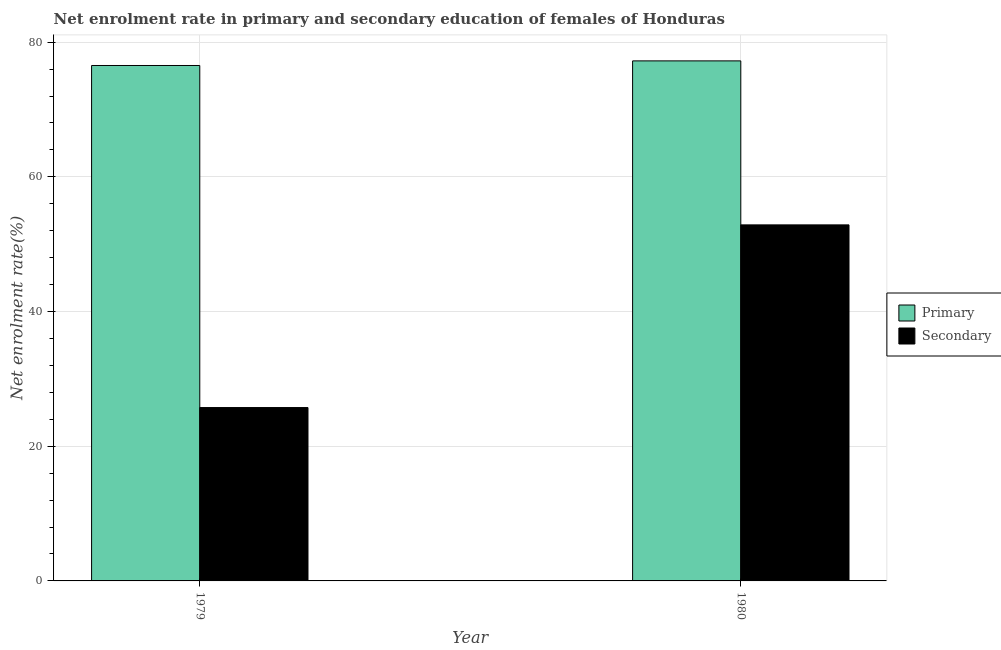How many different coloured bars are there?
Keep it short and to the point. 2. How many bars are there on the 1st tick from the left?
Provide a succinct answer. 2. In how many cases, is the number of bars for a given year not equal to the number of legend labels?
Your answer should be very brief. 0. What is the enrollment rate in secondary education in 1980?
Offer a very short reply. 52.87. Across all years, what is the maximum enrollment rate in secondary education?
Offer a terse response. 52.87. Across all years, what is the minimum enrollment rate in secondary education?
Offer a terse response. 25.74. In which year was the enrollment rate in secondary education minimum?
Provide a succinct answer. 1979. What is the total enrollment rate in secondary education in the graph?
Offer a terse response. 78.61. What is the difference between the enrollment rate in primary education in 1979 and that in 1980?
Your answer should be compact. -0.68. What is the difference between the enrollment rate in primary education in 1979 and the enrollment rate in secondary education in 1980?
Your answer should be very brief. -0.68. What is the average enrollment rate in secondary education per year?
Your response must be concise. 39.31. What is the ratio of the enrollment rate in primary education in 1979 to that in 1980?
Ensure brevity in your answer.  0.99. What does the 1st bar from the left in 1979 represents?
Ensure brevity in your answer.  Primary. What does the 1st bar from the right in 1979 represents?
Provide a succinct answer. Secondary. How many bars are there?
Provide a succinct answer. 4. How many years are there in the graph?
Provide a succinct answer. 2. Are the values on the major ticks of Y-axis written in scientific E-notation?
Keep it short and to the point. No. What is the title of the graph?
Your answer should be compact. Net enrolment rate in primary and secondary education of females of Honduras. What is the label or title of the Y-axis?
Give a very brief answer. Net enrolment rate(%). What is the Net enrolment rate(%) in Primary in 1979?
Your response must be concise. 76.54. What is the Net enrolment rate(%) of Secondary in 1979?
Give a very brief answer. 25.74. What is the Net enrolment rate(%) in Primary in 1980?
Your answer should be compact. 77.22. What is the Net enrolment rate(%) of Secondary in 1980?
Provide a succinct answer. 52.87. Across all years, what is the maximum Net enrolment rate(%) in Primary?
Make the answer very short. 77.22. Across all years, what is the maximum Net enrolment rate(%) of Secondary?
Give a very brief answer. 52.87. Across all years, what is the minimum Net enrolment rate(%) of Primary?
Your answer should be very brief. 76.54. Across all years, what is the minimum Net enrolment rate(%) of Secondary?
Your response must be concise. 25.74. What is the total Net enrolment rate(%) in Primary in the graph?
Keep it short and to the point. 153.76. What is the total Net enrolment rate(%) of Secondary in the graph?
Give a very brief answer. 78.61. What is the difference between the Net enrolment rate(%) of Primary in 1979 and that in 1980?
Your answer should be very brief. -0.68. What is the difference between the Net enrolment rate(%) in Secondary in 1979 and that in 1980?
Make the answer very short. -27.13. What is the difference between the Net enrolment rate(%) of Primary in 1979 and the Net enrolment rate(%) of Secondary in 1980?
Your answer should be very brief. 23.67. What is the average Net enrolment rate(%) of Primary per year?
Offer a very short reply. 76.88. What is the average Net enrolment rate(%) of Secondary per year?
Your answer should be very brief. 39.31. In the year 1979, what is the difference between the Net enrolment rate(%) in Primary and Net enrolment rate(%) in Secondary?
Your answer should be compact. 50.8. In the year 1980, what is the difference between the Net enrolment rate(%) of Primary and Net enrolment rate(%) of Secondary?
Provide a short and direct response. 24.35. What is the ratio of the Net enrolment rate(%) of Primary in 1979 to that in 1980?
Your answer should be very brief. 0.99. What is the ratio of the Net enrolment rate(%) of Secondary in 1979 to that in 1980?
Give a very brief answer. 0.49. What is the difference between the highest and the second highest Net enrolment rate(%) of Primary?
Your answer should be very brief. 0.68. What is the difference between the highest and the second highest Net enrolment rate(%) of Secondary?
Give a very brief answer. 27.13. What is the difference between the highest and the lowest Net enrolment rate(%) of Primary?
Keep it short and to the point. 0.68. What is the difference between the highest and the lowest Net enrolment rate(%) of Secondary?
Offer a very short reply. 27.13. 